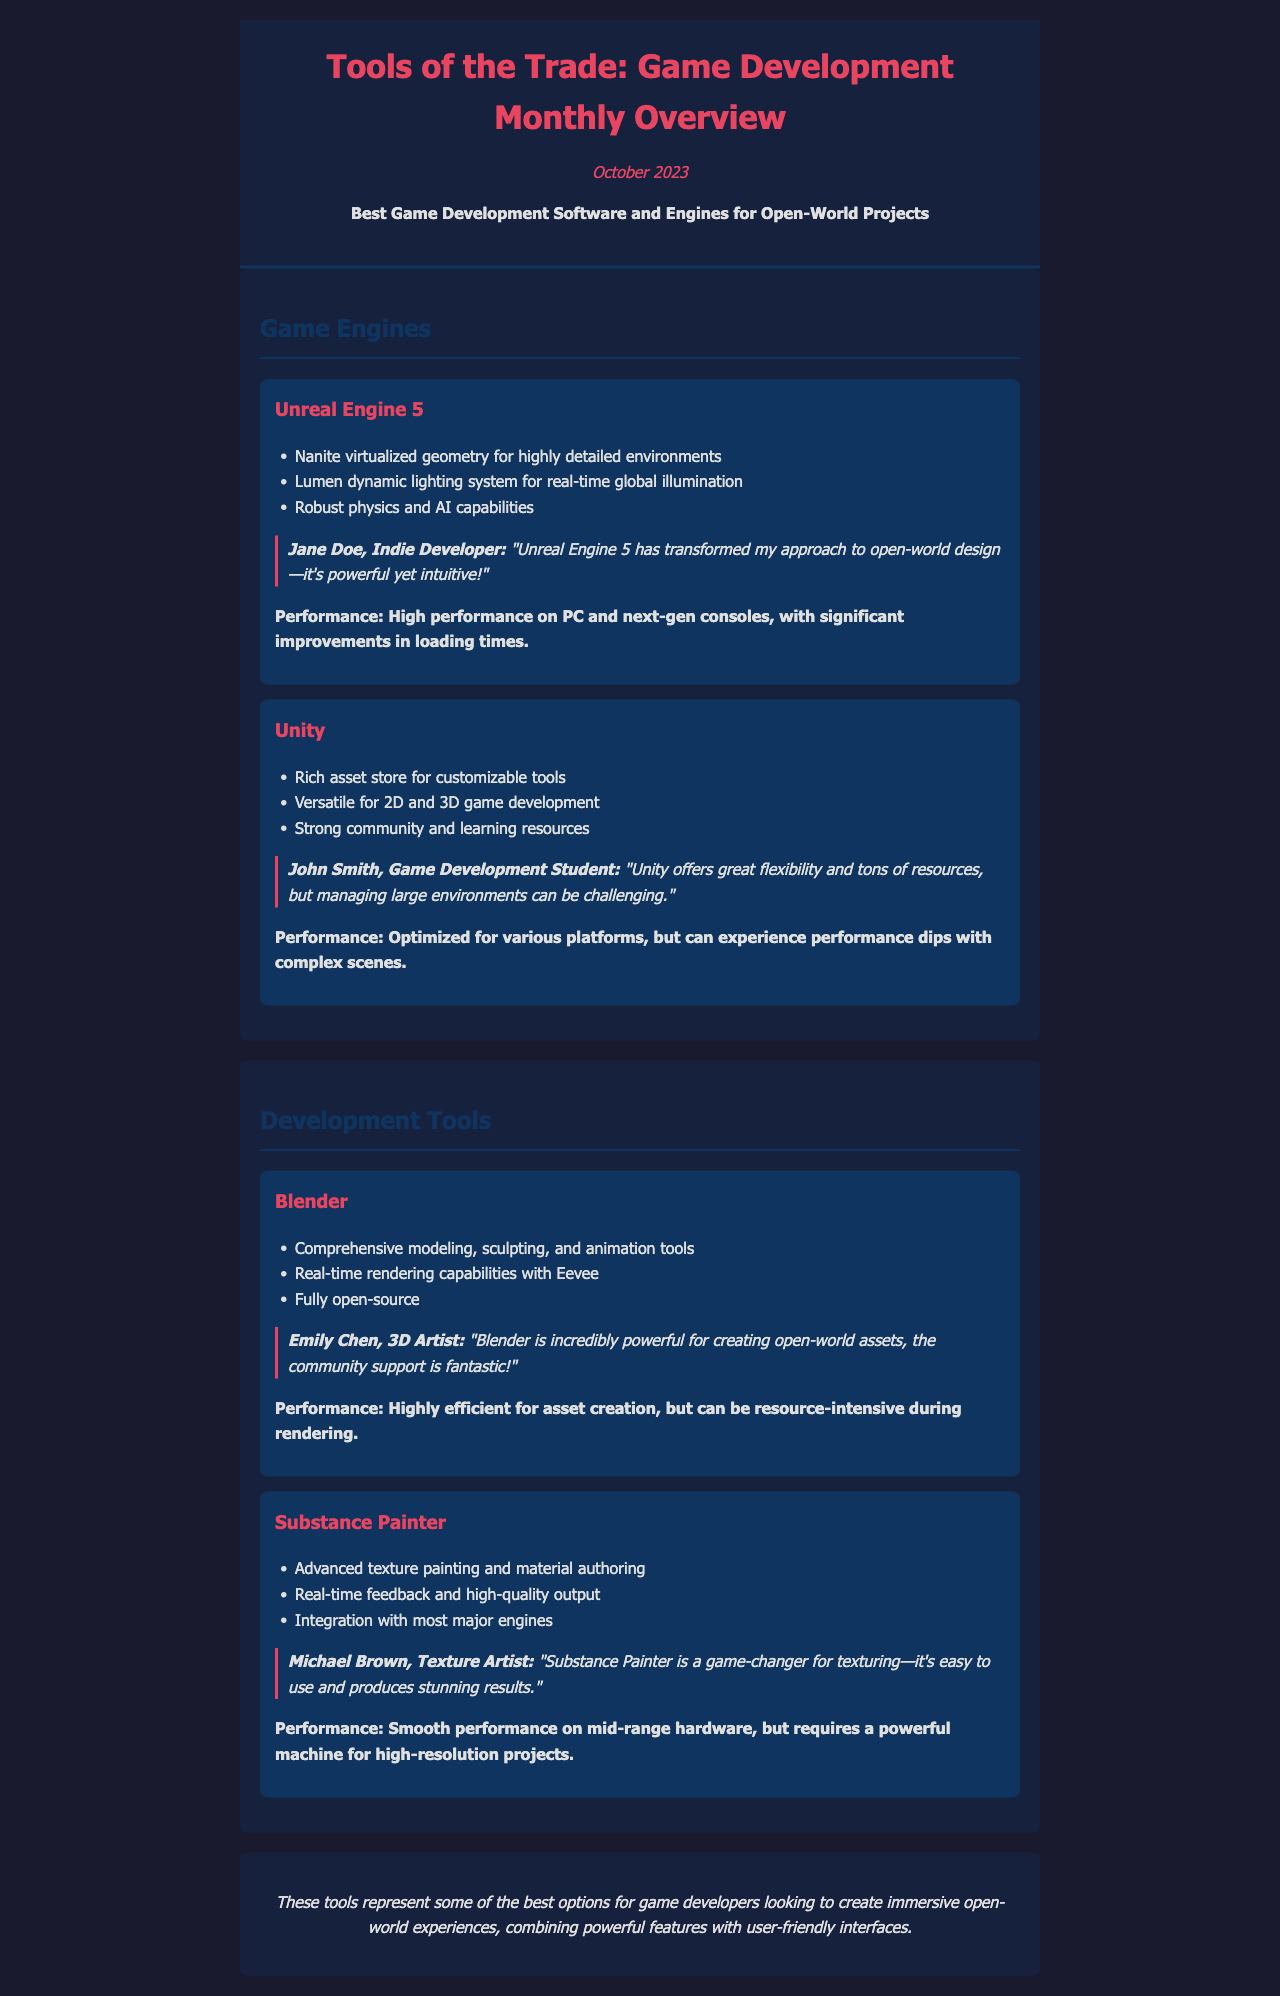What is the title of the newsletter? The title of the newsletter is prominently displayed at the top, which is "Tools of the Trade: Game Development Monthly Overview."
Answer: Tools of the Trade: Game Development Monthly Overview What is the issue month and year? The issue month and year can be found in the header section of the newsletter, specifically marked "October 2023."
Answer: October 2023 Which game engine features Nanite virtualized geometry? The document specifies that "Unreal Engine 5" has Nanite virtualized geometry for highly detailed environments.
Answer: Unreal Engine 5 What is one advantage of using Unity according to the user review? The user review mentions that "Unity offers great flexibility and tons of resources," highlighting its strengths.
Answer: Flexibility Who is the reviewer for Blender? The review for Blender is attributed to "Emily Chen, 3D Artist," which indicates a user's experience.
Answer: Emily Chen, 3D Artist How does Substance Painter perform on mid-range hardware? The document states that "Substance Painter" has "smooth performance on mid-range hardware."
Answer: Smooth performance What gaming aspect does Unreal Engine 5 improve significantly? The newsletter notes that Unreal Engine 5 provides "significant improvements in loading times."
Answer: Loading times What type of rendering capabilities does Blender offer? According to the document, Blender provides "real-time rendering capabilities with Eevee."
Answer: Real-time rendering Which development tool is described as fully open-source? The document explicitly states that Blender is "fully open-source."
Answer: Blender 